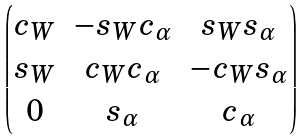<formula> <loc_0><loc_0><loc_500><loc_500>\begin{pmatrix} c _ { W } & - s _ { W } c _ { \alpha } & s _ { W } s _ { \alpha } \\ s _ { W } & c _ { W } c _ { \alpha } & - c _ { W } s _ { \alpha } \\ 0 & s _ { \alpha } & c _ { \alpha } \end{pmatrix}</formula> 